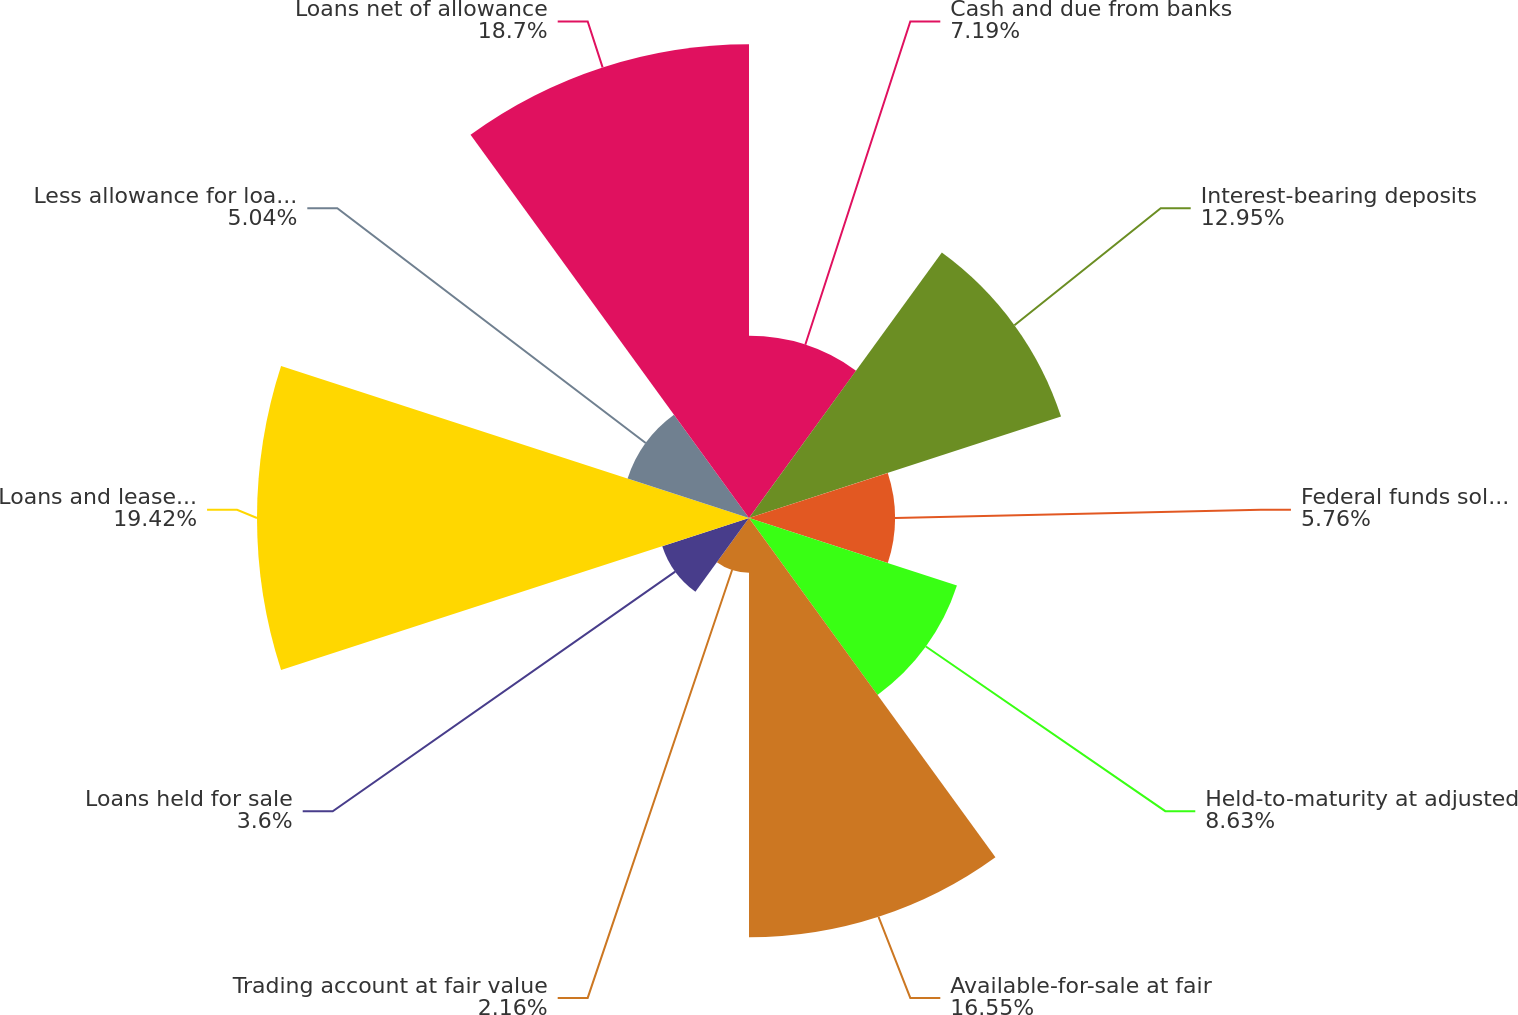Convert chart. <chart><loc_0><loc_0><loc_500><loc_500><pie_chart><fcel>Cash and due from banks<fcel>Interest-bearing deposits<fcel>Federal funds sold and<fcel>Held-to-maturity at adjusted<fcel>Available-for-sale at fair<fcel>Trading account at fair value<fcel>Loans held for sale<fcel>Loans and leases net of<fcel>Less allowance for loan losses<fcel>Loans net of allowance<nl><fcel>7.19%<fcel>12.95%<fcel>5.76%<fcel>8.63%<fcel>16.55%<fcel>2.16%<fcel>3.6%<fcel>19.42%<fcel>5.04%<fcel>18.7%<nl></chart> 